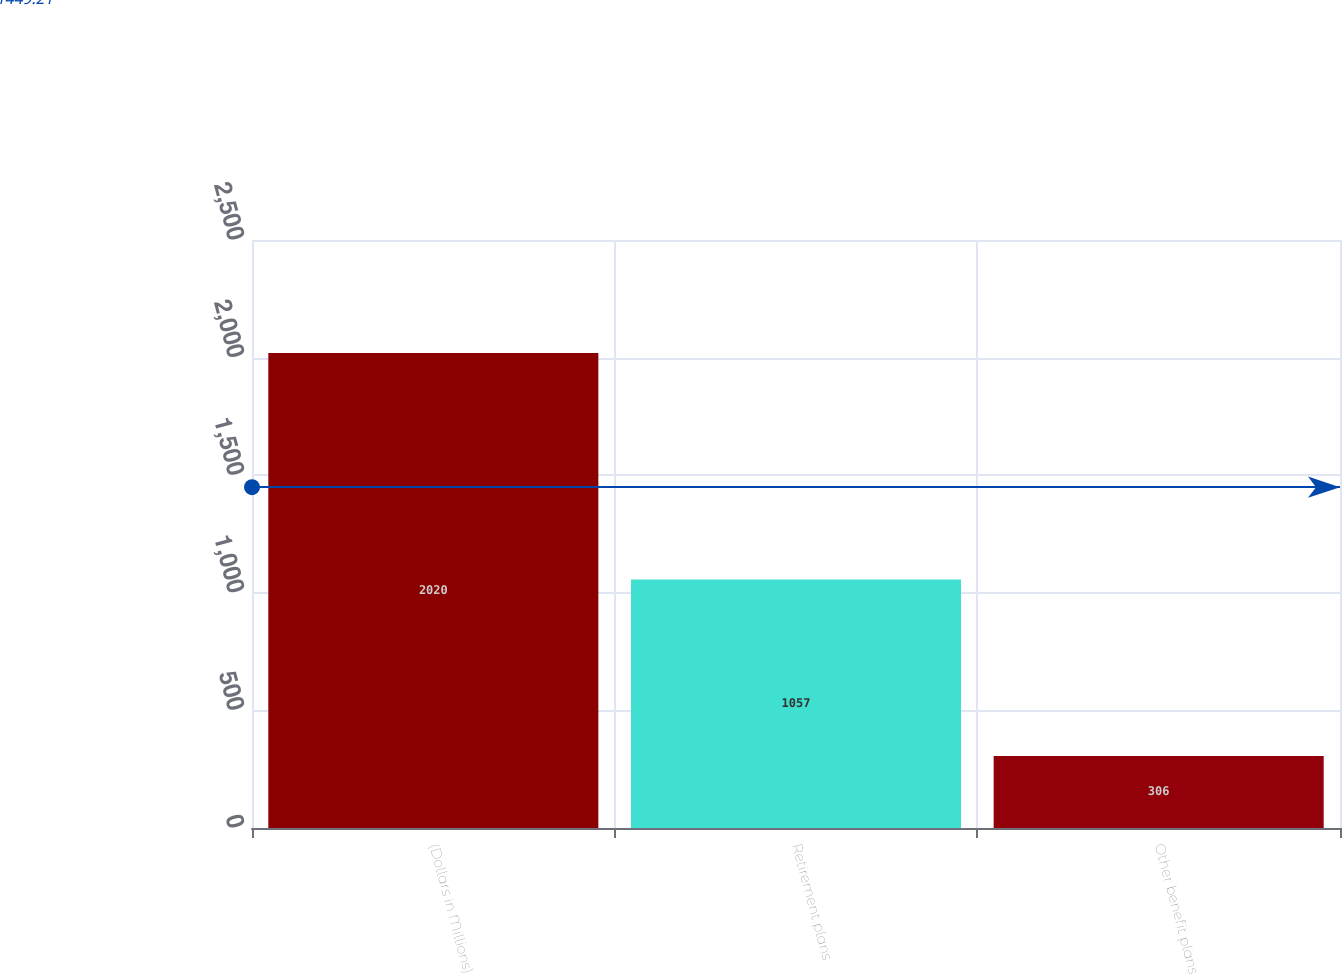<chart> <loc_0><loc_0><loc_500><loc_500><bar_chart><fcel>(Dollars in Millions)<fcel>Retirement plans<fcel>Other benefit plans<nl><fcel>2020<fcel>1057<fcel>306<nl></chart> 